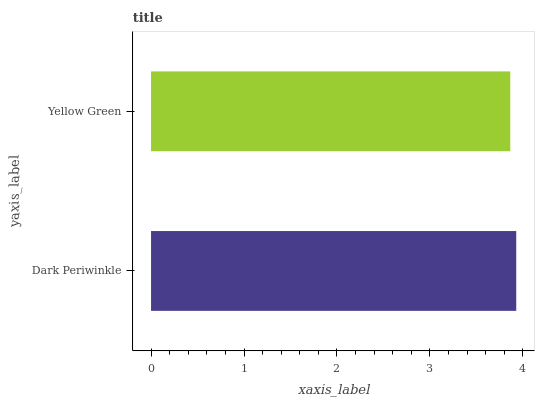Is Yellow Green the minimum?
Answer yes or no. Yes. Is Dark Periwinkle the maximum?
Answer yes or no. Yes. Is Yellow Green the maximum?
Answer yes or no. No. Is Dark Periwinkle greater than Yellow Green?
Answer yes or no. Yes. Is Yellow Green less than Dark Periwinkle?
Answer yes or no. Yes. Is Yellow Green greater than Dark Periwinkle?
Answer yes or no. No. Is Dark Periwinkle less than Yellow Green?
Answer yes or no. No. Is Dark Periwinkle the high median?
Answer yes or no. Yes. Is Yellow Green the low median?
Answer yes or no. Yes. Is Yellow Green the high median?
Answer yes or no. No. Is Dark Periwinkle the low median?
Answer yes or no. No. 